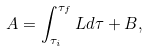<formula> <loc_0><loc_0><loc_500><loc_500>A = \int _ { \tau _ { i } } ^ { \tau _ { f } } L d \tau + B ,</formula> 